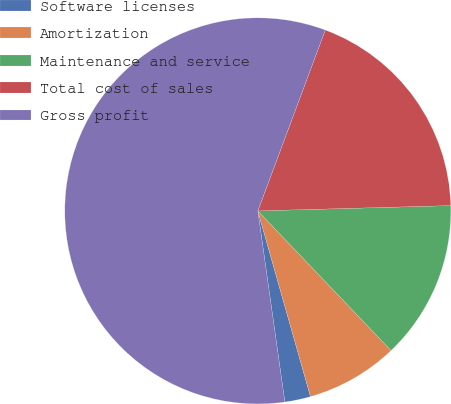Convert chart to OTSL. <chart><loc_0><loc_0><loc_500><loc_500><pie_chart><fcel>Software licenses<fcel>Amortization<fcel>Maintenance and service<fcel>Total cost of sales<fcel>Gross profit<nl><fcel>2.16%<fcel>7.73%<fcel>13.31%<fcel>18.88%<fcel>57.92%<nl></chart> 